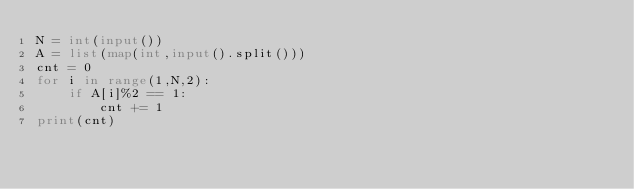<code> <loc_0><loc_0><loc_500><loc_500><_Python_>N = int(input())
A = list(map(int,input().split()))
cnt = 0
for i in range(1,N,2):
    if A[i]%2 == 1:
        cnt += 1
print(cnt)
</code> 